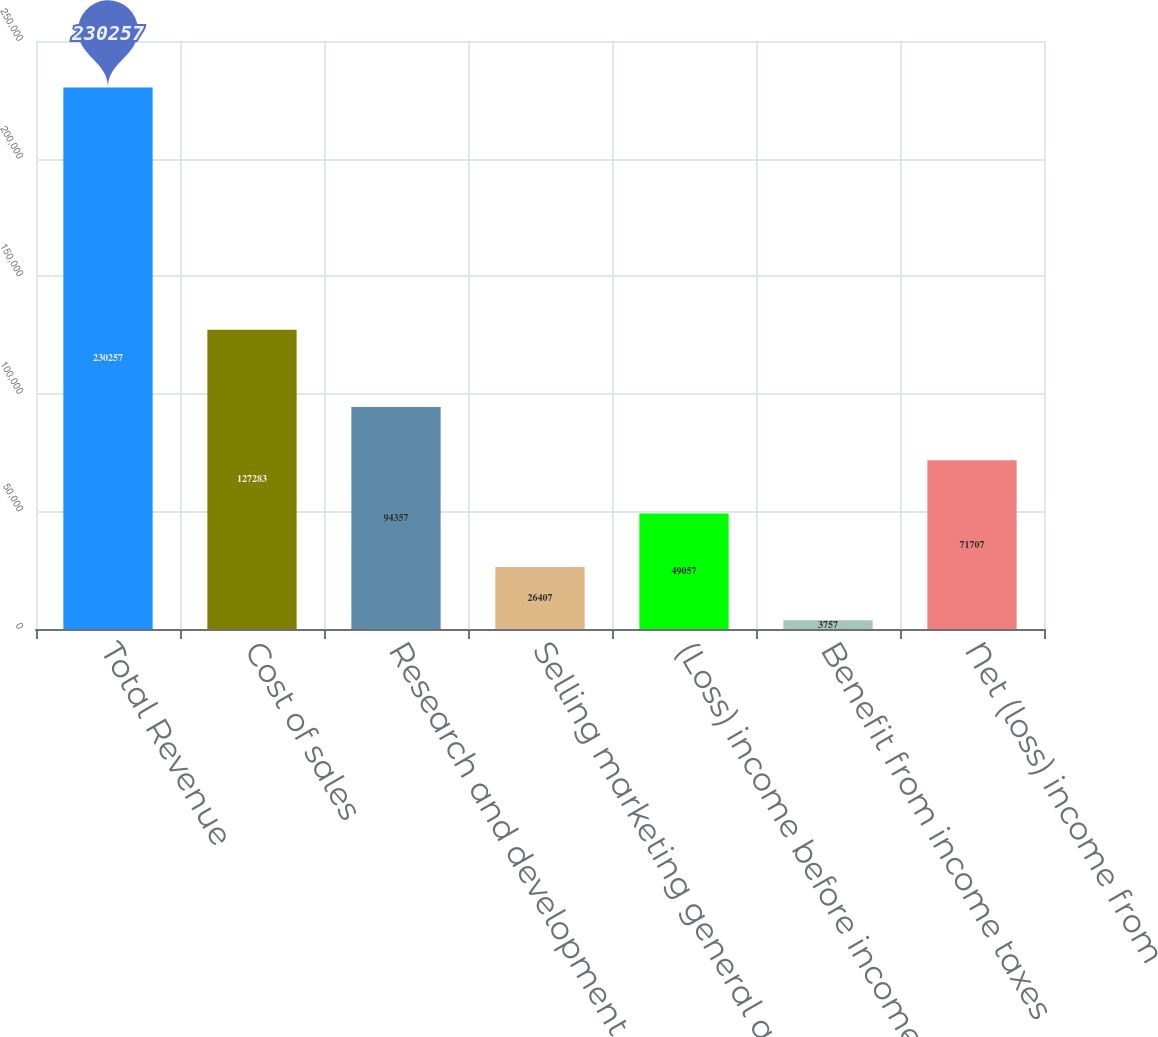Convert chart to OTSL. <chart><loc_0><loc_0><loc_500><loc_500><bar_chart><fcel>Total Revenue<fcel>Cost of sales<fcel>Research and development<fcel>Selling marketing general and<fcel>(Loss) income before income<fcel>Benefit from income taxes<fcel>Net (loss) income from<nl><fcel>230257<fcel>127283<fcel>94357<fcel>26407<fcel>49057<fcel>3757<fcel>71707<nl></chart> 